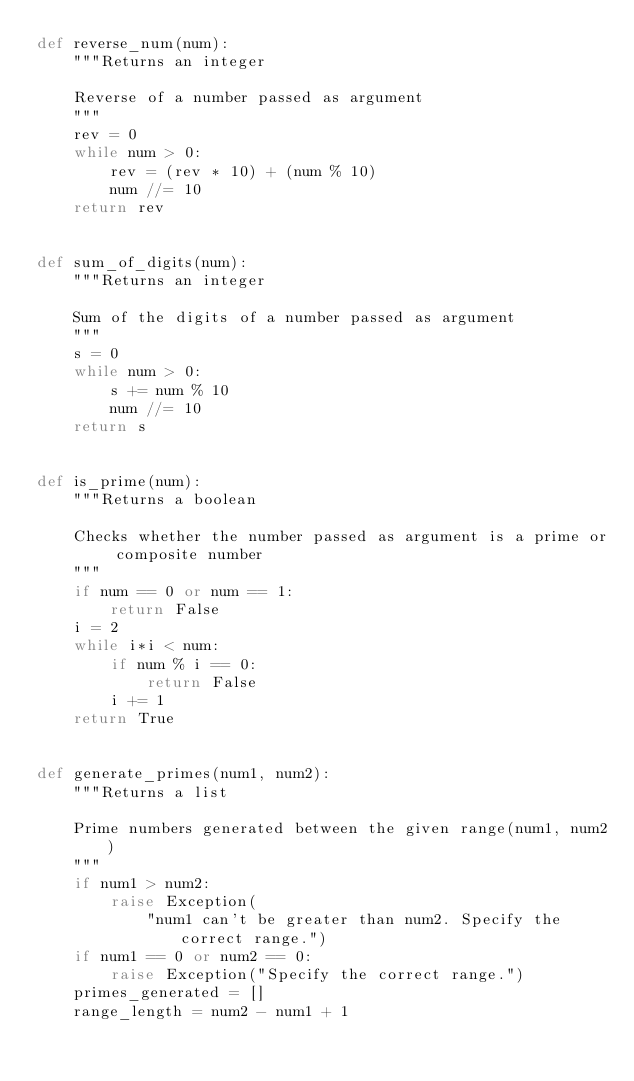<code> <loc_0><loc_0><loc_500><loc_500><_Python_>def reverse_num(num):
    """Returns an integer

    Reverse of a number passed as argument
    """
    rev = 0
    while num > 0:
        rev = (rev * 10) + (num % 10)
        num //= 10
    return rev


def sum_of_digits(num):
    """Returns an integer

    Sum of the digits of a number passed as argument
    """
    s = 0
    while num > 0:
        s += num % 10
        num //= 10
    return s


def is_prime(num):
    """Returns a boolean 

    Checks whether the number passed as argument is a prime or composite number
    """
    if num == 0 or num == 1:
        return False
    i = 2
    while i*i < num:
        if num % i == 0:
            return False
        i += 1
    return True


def generate_primes(num1, num2):
    """Returns a list

    Prime numbers generated between the given range(num1, num2)
    """
    if num1 > num2:
        raise Exception(
            "num1 can't be greater than num2. Specify the correct range.")
    if num1 == 0 or num2 == 0:
        raise Exception("Specify the correct range.")
    primes_generated = []
    range_length = num2 - num1 + 1</code> 